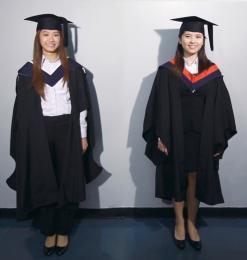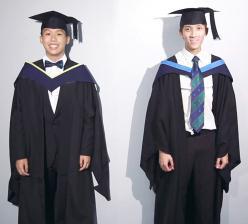The first image is the image on the left, the second image is the image on the right. For the images displayed, is the sentence "Two graduates pose for a picture in one of the images." factually correct? Answer yes or no. Yes. 